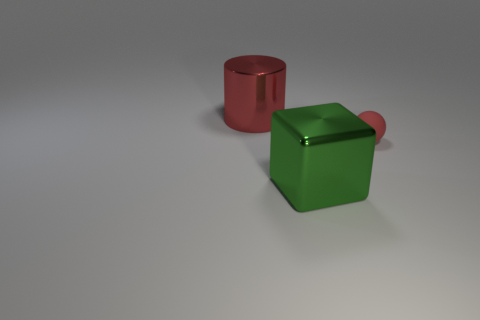Subtract 0 cyan spheres. How many objects are left? 3 Subtract all cylinders. How many objects are left? 2 Subtract all gray cylinders. Subtract all red cubes. How many cylinders are left? 1 Subtract all green metal cubes. Subtract all big metal cubes. How many objects are left? 1 Add 1 shiny cubes. How many shiny cubes are left? 2 Add 1 tiny purple matte blocks. How many tiny purple matte blocks exist? 1 Add 1 purple things. How many objects exist? 4 